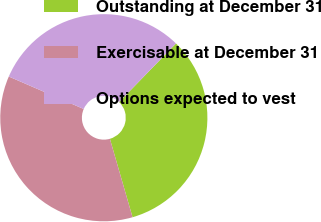Convert chart to OTSL. <chart><loc_0><loc_0><loc_500><loc_500><pie_chart><fcel>Outstanding at December 31<fcel>Exercisable at December 31<fcel>Options expected to vest<nl><fcel>33.26%<fcel>35.99%<fcel>30.76%<nl></chart> 